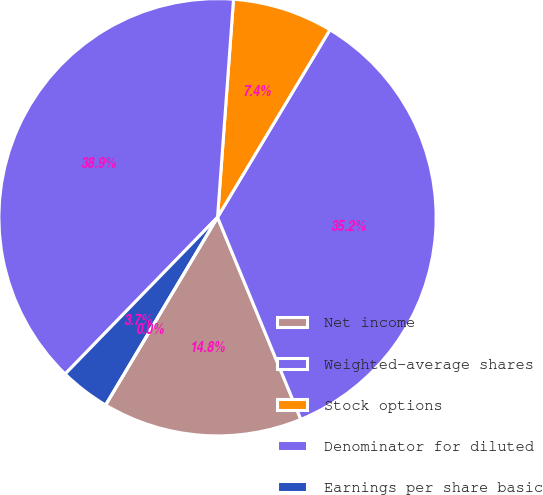Convert chart. <chart><loc_0><loc_0><loc_500><loc_500><pie_chart><fcel>Net income<fcel>Weighted-average shares<fcel>Stock options<fcel>Denominator for diluted<fcel>Earnings per share basic<fcel>Earnings per share diluted<nl><fcel>14.78%<fcel>35.18%<fcel>7.43%<fcel>38.89%<fcel>3.72%<fcel>0.0%<nl></chart> 